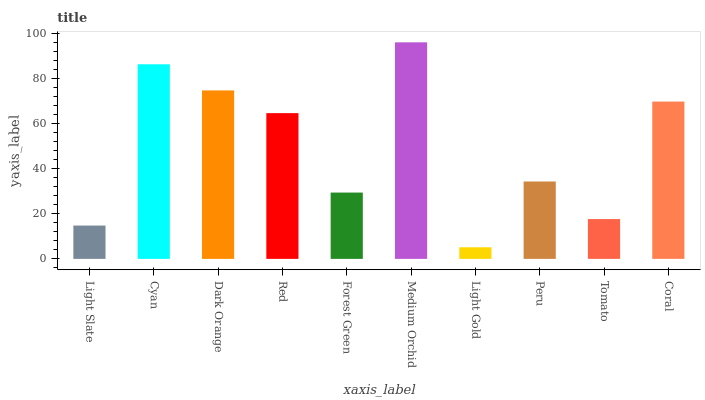Is Light Gold the minimum?
Answer yes or no. Yes. Is Medium Orchid the maximum?
Answer yes or no. Yes. Is Cyan the minimum?
Answer yes or no. No. Is Cyan the maximum?
Answer yes or no. No. Is Cyan greater than Light Slate?
Answer yes or no. Yes. Is Light Slate less than Cyan?
Answer yes or no. Yes. Is Light Slate greater than Cyan?
Answer yes or no. No. Is Cyan less than Light Slate?
Answer yes or no. No. Is Red the high median?
Answer yes or no. Yes. Is Peru the low median?
Answer yes or no. Yes. Is Light Slate the high median?
Answer yes or no. No. Is Light Gold the low median?
Answer yes or no. No. 